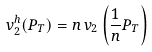Convert formula to latex. <formula><loc_0><loc_0><loc_500><loc_500>v ^ { h } _ { 2 } ( P _ { T } ) = n \, v _ { 2 } \left ( \frac { 1 } { n } P _ { T } \right )</formula> 